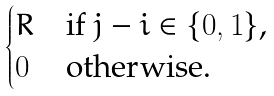<formula> <loc_0><loc_0><loc_500><loc_500>\begin{cases} R & \text {if $j-i \in \{0,1\}$,} \\ 0 & \text {otherwise.} \end{cases}</formula> 